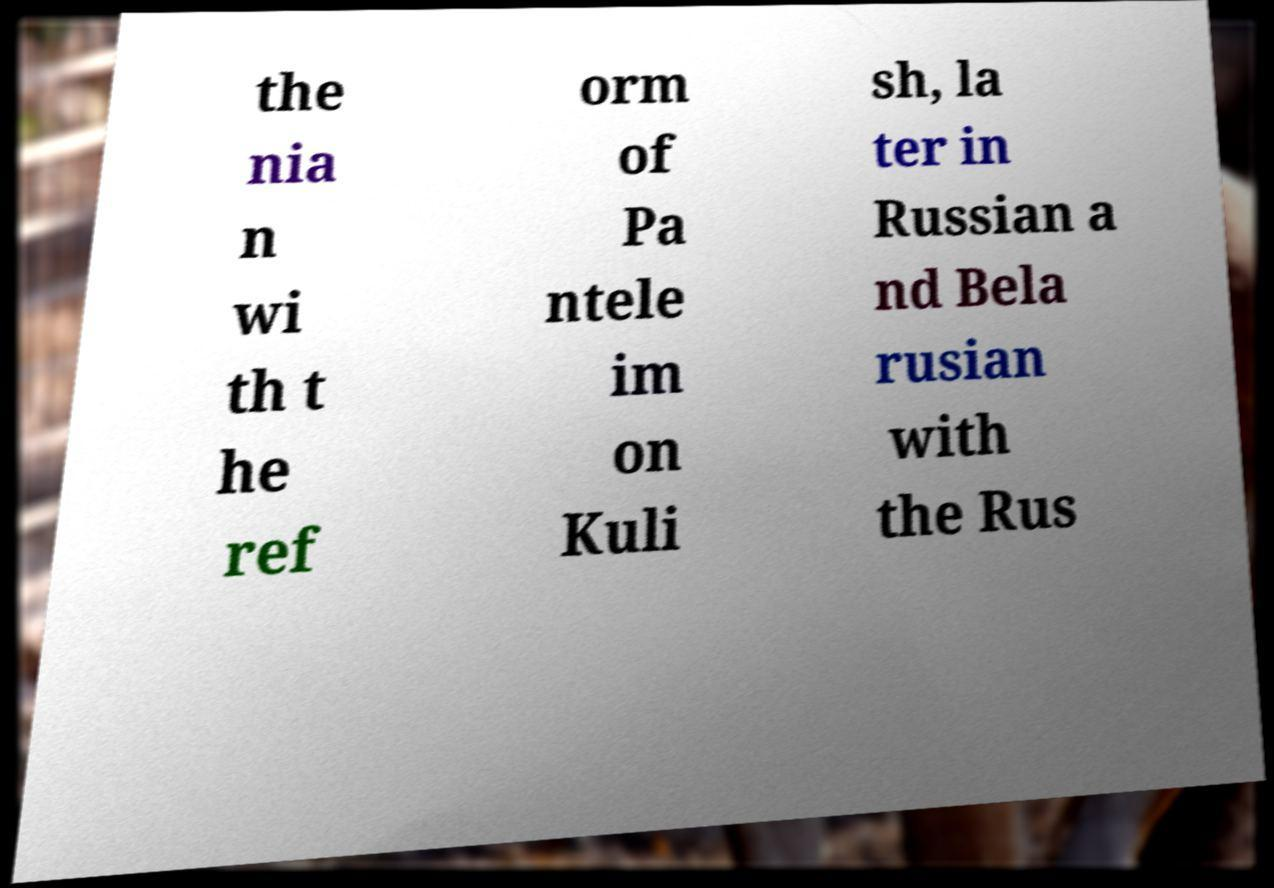Please identify and transcribe the text found in this image. the nia n wi th t he ref orm of Pa ntele im on Kuli sh, la ter in Russian a nd Bela rusian with the Rus 